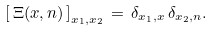<formula> <loc_0><loc_0><loc_500><loc_500>\left [ \, \Xi ( x , n ) \, \right ] _ { x _ { 1 } , x _ { 2 } } \, = \, \delta _ { x _ { 1 } , x } \, \delta _ { x _ { 2 } , n } .</formula> 